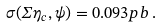<formula> <loc_0><loc_0><loc_500><loc_500>\sigma ( \Sigma \eta _ { c } , \psi ) = 0 . 0 9 3 p b \, .</formula> 